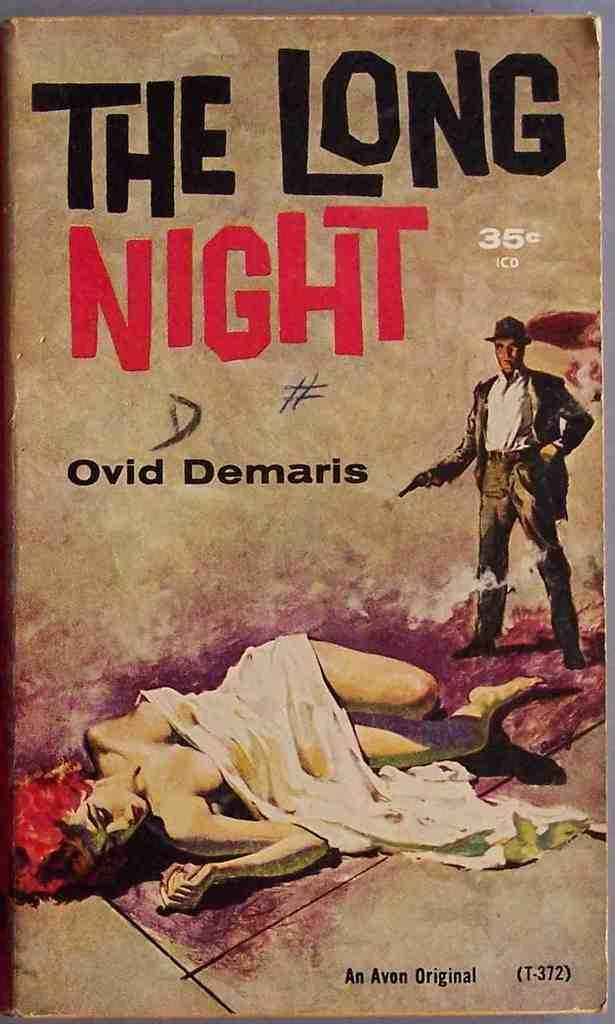<image>
Summarize the visual content of the image. A book that is an Avon Original and has the number T-372 on the cover. 